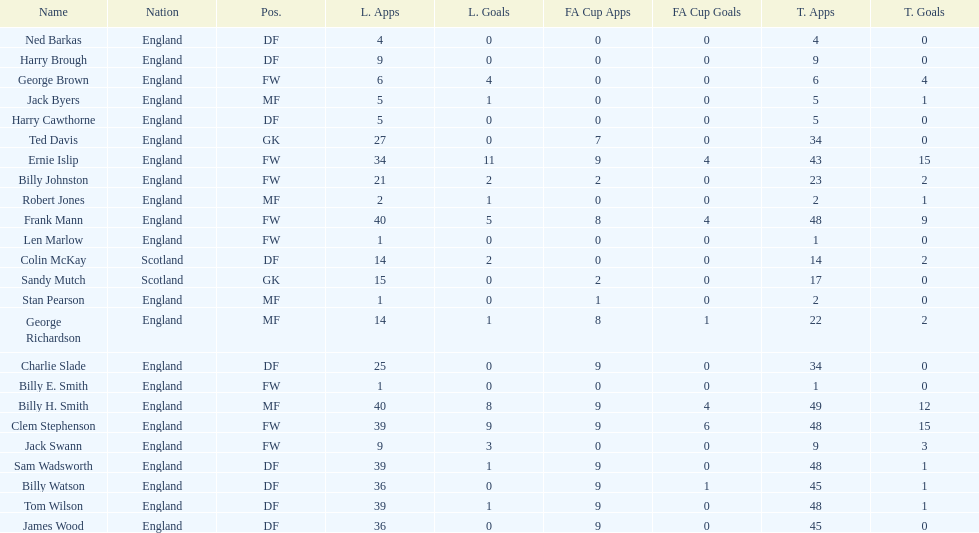How many players are fws? 8. 